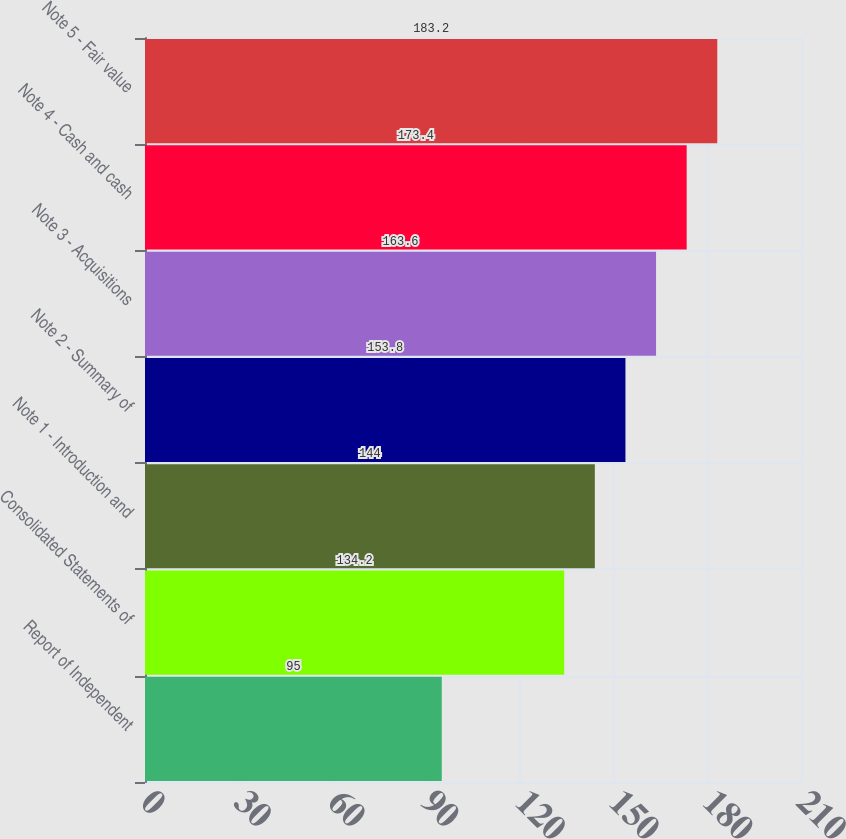Convert chart. <chart><loc_0><loc_0><loc_500><loc_500><bar_chart><fcel>Report of Independent<fcel>Consolidated Statements of<fcel>Note 1 - Introduction and<fcel>Note 2 - Summary of<fcel>Note 3 - Acquisitions<fcel>Note 4 - Cash and cash<fcel>Note 5 - Fair value<nl><fcel>95<fcel>134.2<fcel>144<fcel>153.8<fcel>163.6<fcel>173.4<fcel>183.2<nl></chart> 